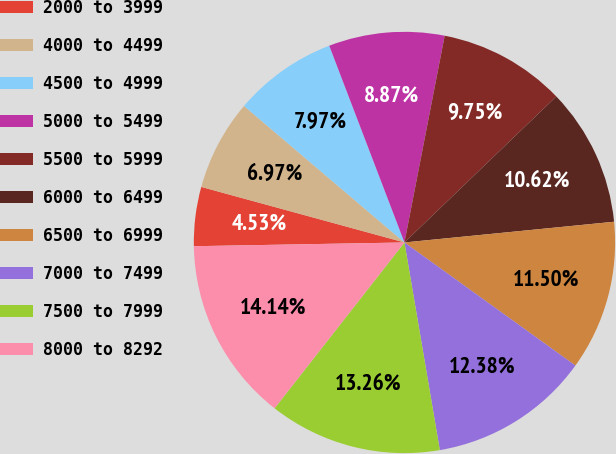Convert chart to OTSL. <chart><loc_0><loc_0><loc_500><loc_500><pie_chart><fcel>2000 to 3999<fcel>4000 to 4499<fcel>4500 to 4999<fcel>5000 to 5499<fcel>5500 to 5999<fcel>6000 to 6499<fcel>6500 to 6999<fcel>7000 to 7499<fcel>7500 to 7999<fcel>8000 to 8292<nl><fcel>4.53%<fcel>6.97%<fcel>7.97%<fcel>8.87%<fcel>9.75%<fcel>10.62%<fcel>11.5%<fcel>12.38%<fcel>13.26%<fcel>14.14%<nl></chart> 